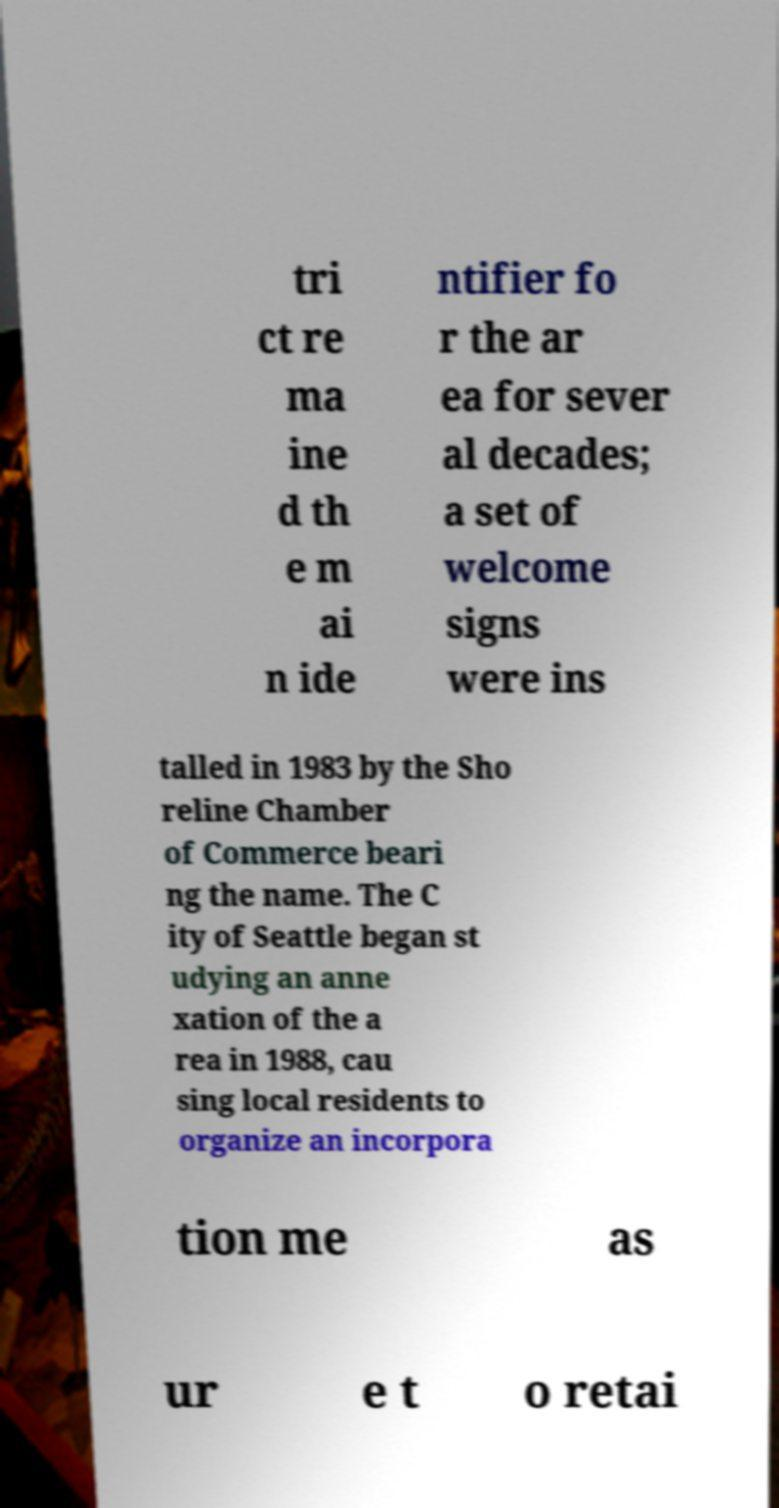Could you extract and type out the text from this image? tri ct re ma ine d th e m ai n ide ntifier fo r the ar ea for sever al decades; a set of welcome signs were ins talled in 1983 by the Sho reline Chamber of Commerce beari ng the name. The C ity of Seattle began st udying an anne xation of the a rea in 1988, cau sing local residents to organize an incorpora tion me as ur e t o retai 